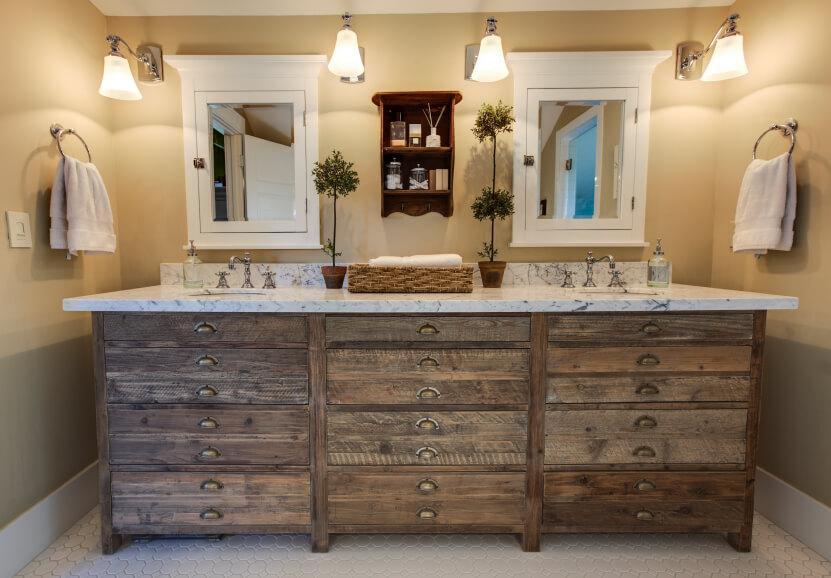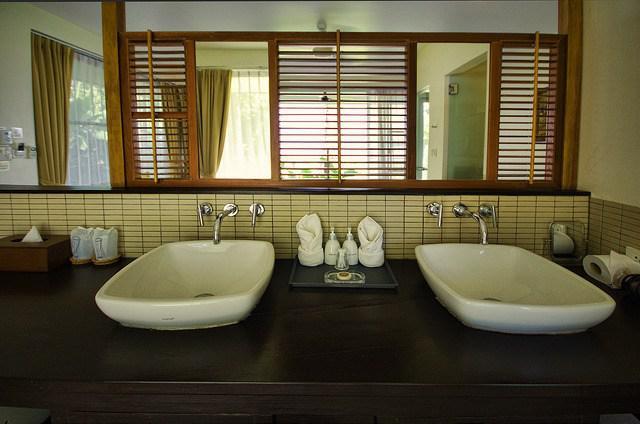The first image is the image on the left, the second image is the image on the right. For the images shown, is this caption "There is a double vanity and a single vanity." true? Answer yes or no. No. The first image is the image on the left, the second image is the image on the right. For the images shown, is this caption "There is one vase with flowers in the right image." true? Answer yes or no. No. 